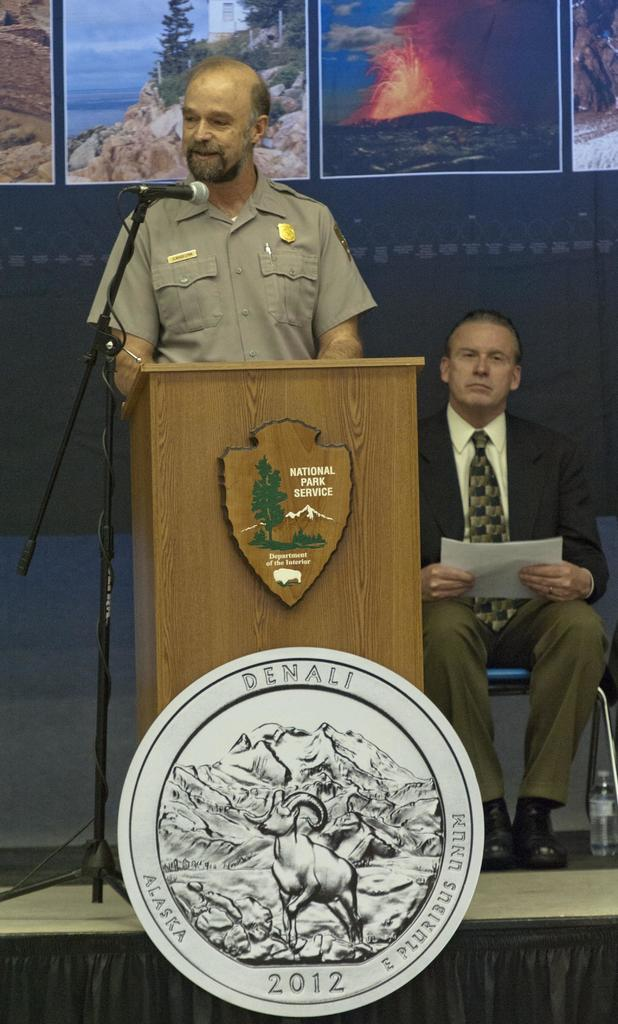Provide a one-sentence caption for the provided image. The speaker here is from the National Park Service. 